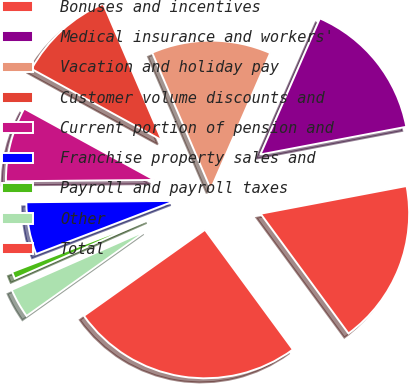<chart> <loc_0><loc_0><loc_500><loc_500><pie_chart><fcel>Bonuses and incentives<fcel>Medical insurance and workers'<fcel>Vacation and holiday pay<fcel>Customer volume discounts and<fcel>Current portion of pension and<fcel>Franchise property sales and<fcel>Payroll and payroll taxes<fcel>Other<fcel>Total<nl><fcel>17.91%<fcel>15.46%<fcel>13.01%<fcel>10.57%<fcel>8.12%<fcel>5.68%<fcel>0.78%<fcel>3.23%<fcel>25.24%<nl></chart> 